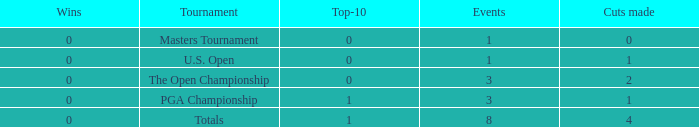For majors with 8 events played and more than 1 made cut, what is the most top-10s recorded? 1.0. 